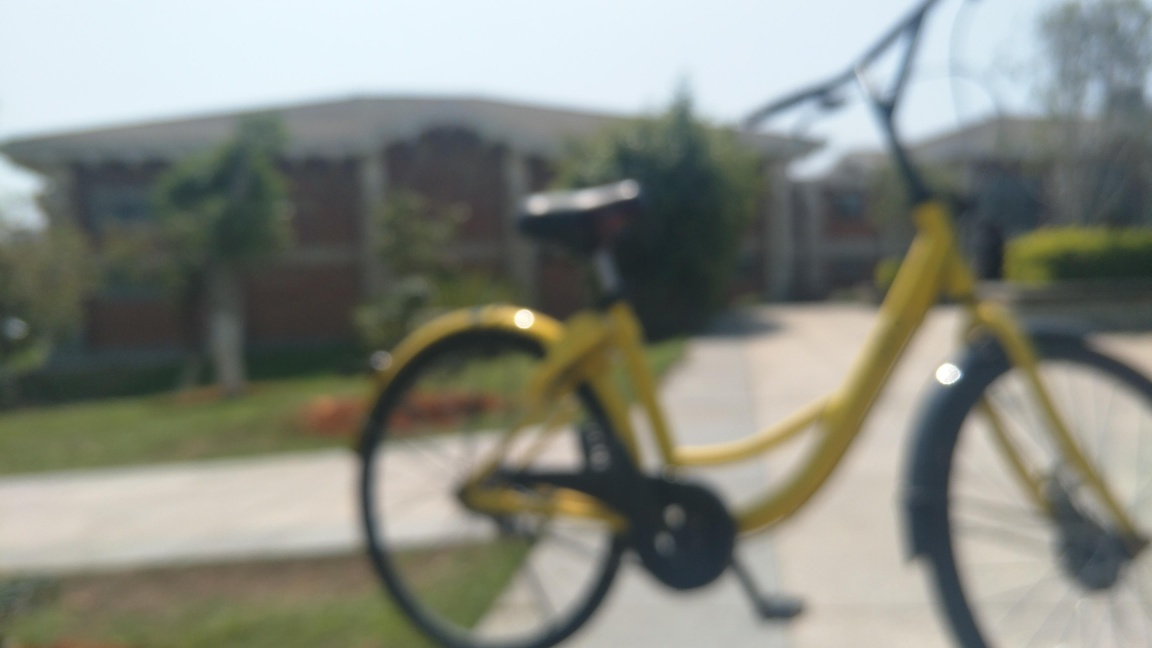Can you describe the main subject of the photo? The main subject of the photo appears to be a yellow bicycle in the foreground; however, it is not clearly visible due to the focus being set on a distant point, possibly beyond the bike. Is there anything noticeable in the background? The background features what looks like a building with a distinctive roof and a well-maintained lawn in front of it, suggesting a tranquil suburban or campus setting, though specifics are difficult to make out due to the blurred focus. 